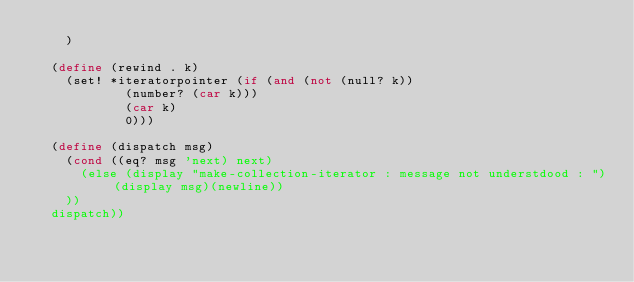Convert code to text. <code><loc_0><loc_0><loc_500><loc_500><_Scheme_>		) 	

	(define (rewind . k)
		(set! *iteratorpointer (if (and (not (null? k)) 
						(number? (car k)))
						(car k)
						0)))

	(define (dispatch msg)
		(cond ((eq? msg 'next) next)
			(else (display "make-collection-iterator : message not understdood : ")(display msg)(newline))
		))
	dispatch))
</code> 